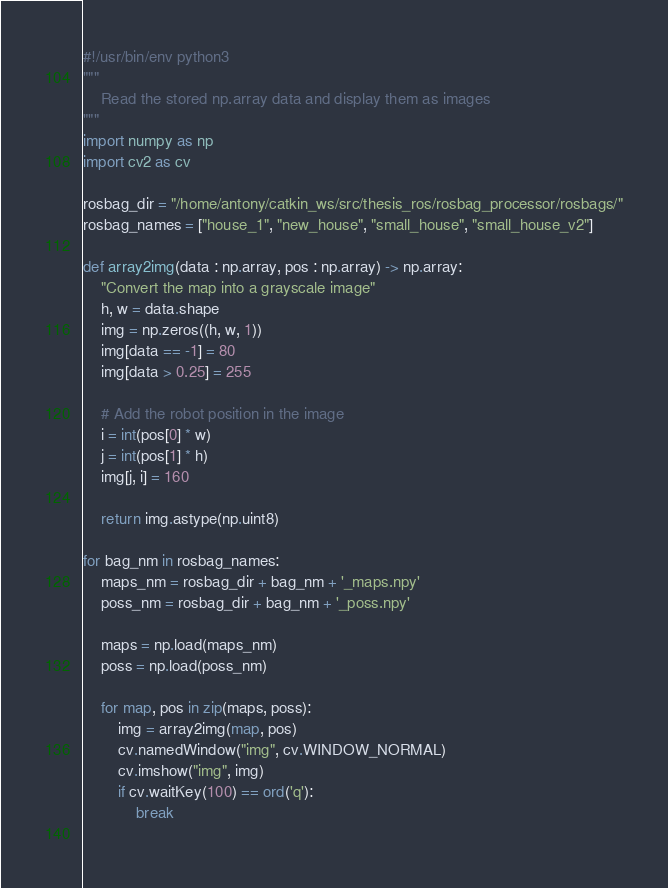<code> <loc_0><loc_0><loc_500><loc_500><_Python_>#!/usr/bin/env python3
""" 
    Read the stored np.array data and display them as images
"""
import numpy as np
import cv2 as cv

rosbag_dir = "/home/antony/catkin_ws/src/thesis_ros/rosbag_processor/rosbags/"
rosbag_names = ["house_1", "new_house", "small_house", "small_house_v2"]

def array2img(data : np.array, pos : np.array) -> np.array:
    "Convert the map into a grayscale image"
    h, w = data.shape
    img = np.zeros((h, w, 1))
    img[data == -1] = 80
    img[data > 0.25] = 255

    # Add the robot position in the image
    i = int(pos[0] * w)
    j = int(pos[1] * h)
    img[j, i] = 160
    
    return img.astype(np.uint8)

for bag_nm in rosbag_names:
    maps_nm = rosbag_dir + bag_nm + '_maps.npy'
    poss_nm = rosbag_dir + bag_nm + '_poss.npy'

    maps = np.load(maps_nm)
    poss = np.load(poss_nm)

    for map, pos in zip(maps, poss):
        img = array2img(map, pos)
        cv.namedWindow("img", cv.WINDOW_NORMAL)
        cv.imshow("img", img)
        if cv.waitKey(100) == ord('q'):
            break
        
</code> 